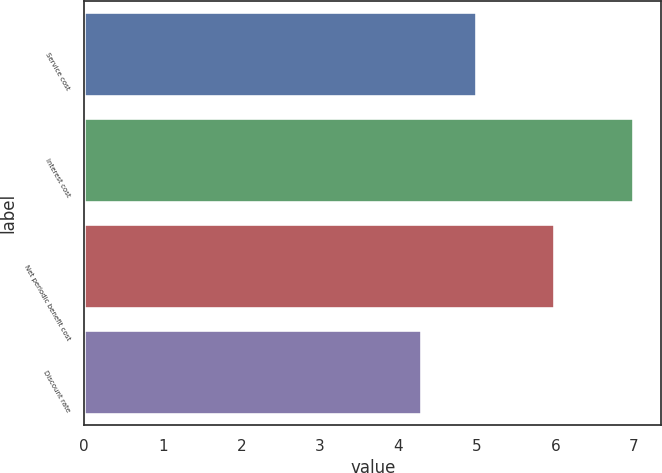<chart> <loc_0><loc_0><loc_500><loc_500><bar_chart><fcel>Service cost<fcel>Interest cost<fcel>Net periodic benefit cost<fcel>Discount rate<nl><fcel>5<fcel>7<fcel>6<fcel>4.3<nl></chart> 